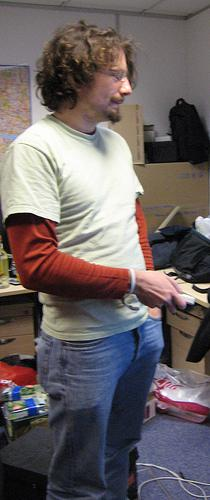Question: where is this man?
Choices:
A. Inside.
B. A room.
C. Bedroom.
D. Kitchen.
Answer with the letter. Answer: B Question: what color is his hair?
Choices:
A. Black.
B. Brown.
C. Blonde.
D. Red.
Answer with the letter. Answer: B Question: what kind of pants is he wearing?
Choices:
A. Slacks.
B. Khakis.
C. Ripped.
D. Jeans.
Answer with the letter. Answer: D Question: what color are the boxes?
Choices:
A. Black.
B. Brown.
C. Blue.
D. Green.
Answer with the letter. Answer: B Question: what color is the man's' undershirt?
Choices:
A. White.
B. Black.
C. Red.
D. Blue.
Answer with the letter. Answer: C Question: how does the man have his left hand?
Choices:
A. Open.
B. In his pocket.
C. A fist.
D. In the air.
Answer with the letter. Answer: B 